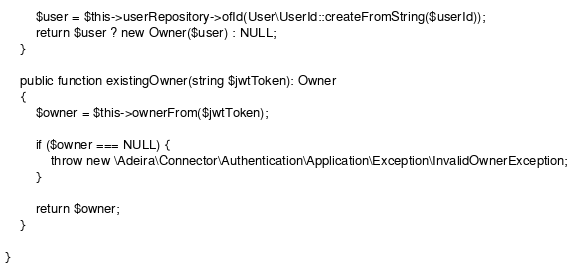<code> <loc_0><loc_0><loc_500><loc_500><_PHP_>
		$user = $this->userRepository->ofId(User\UserId::createFromString($userId));
		return $user ? new Owner($user) : NULL;
	}

	public function existingOwner(string $jwtToken): Owner
	{
		$owner = $this->ownerFrom($jwtToken);

		if ($owner === NULL) {
			throw new \Adeira\Connector\Authentication\Application\Exception\InvalidOwnerException;
		}

		return $owner;
	}

}
</code> 